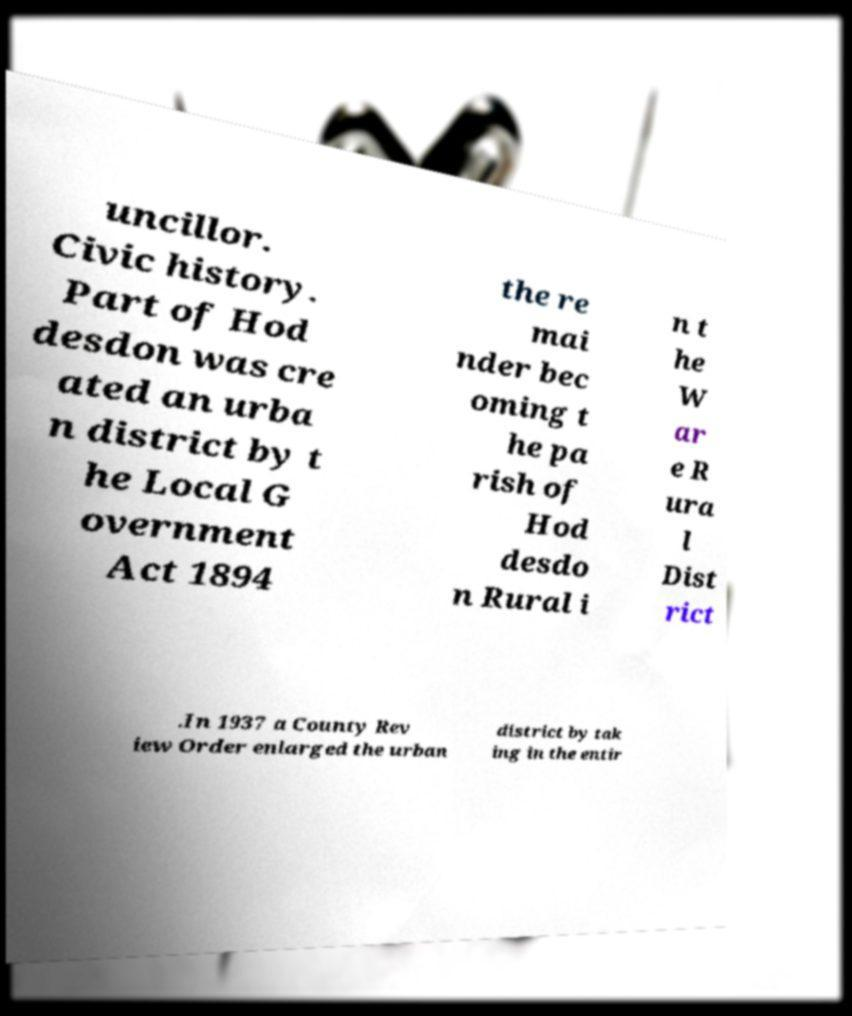Could you assist in decoding the text presented in this image and type it out clearly? uncillor. Civic history. Part of Hod desdon was cre ated an urba n district by t he Local G overnment Act 1894 the re mai nder bec oming t he pa rish of Hod desdo n Rural i n t he W ar e R ura l Dist rict .In 1937 a County Rev iew Order enlarged the urban district by tak ing in the entir 